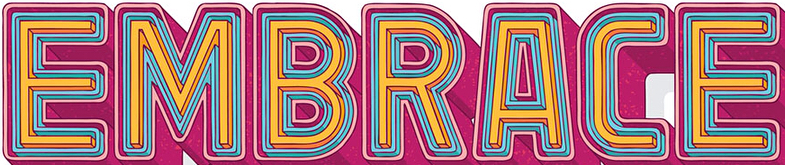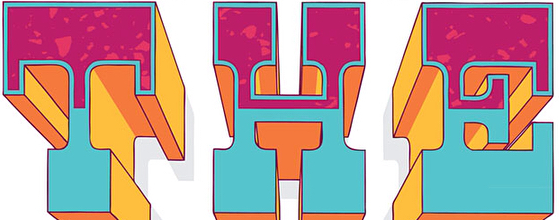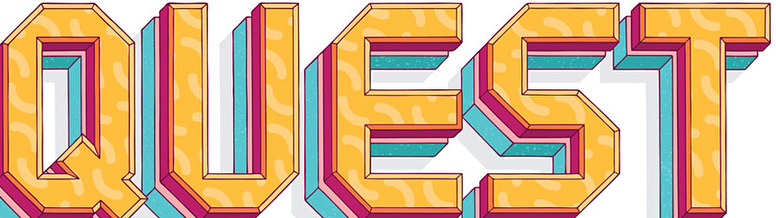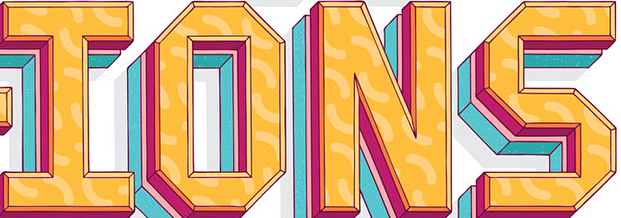What text is displayed in these images sequentially, separated by a semicolon? EMBRACE; THE; QUEST; IONS 